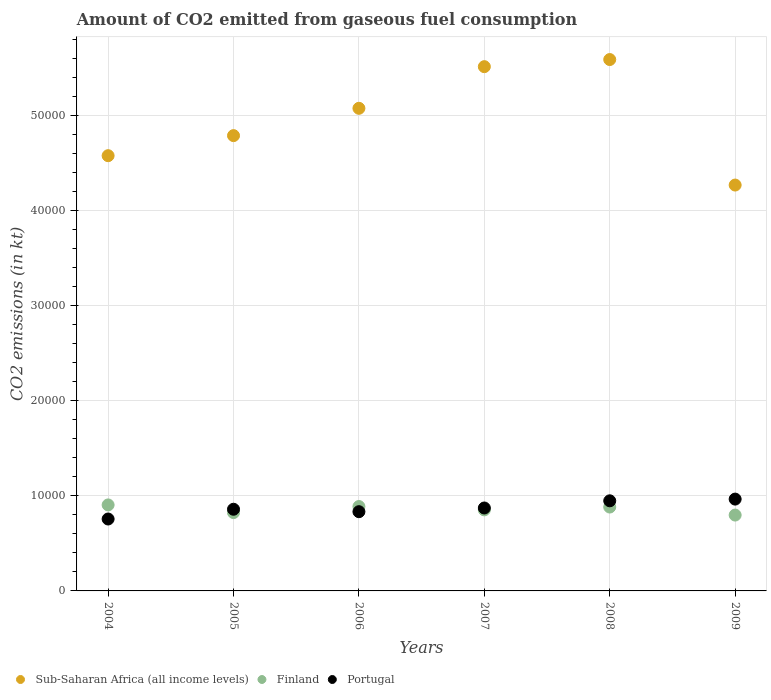Is the number of dotlines equal to the number of legend labels?
Offer a very short reply. Yes. What is the amount of CO2 emitted in Finland in 2004?
Provide a short and direct response. 9046.49. Across all years, what is the maximum amount of CO2 emitted in Finland?
Ensure brevity in your answer.  9046.49. Across all years, what is the minimum amount of CO2 emitted in Sub-Saharan Africa (all income levels)?
Provide a short and direct response. 4.27e+04. In which year was the amount of CO2 emitted in Portugal maximum?
Provide a short and direct response. 2009. In which year was the amount of CO2 emitted in Finland minimum?
Make the answer very short. 2009. What is the total amount of CO2 emitted in Finland in the graph?
Give a very brief answer. 5.15e+04. What is the difference between the amount of CO2 emitted in Sub-Saharan Africa (all income levels) in 2004 and that in 2008?
Provide a short and direct response. -1.01e+04. What is the difference between the amount of CO2 emitted in Sub-Saharan Africa (all income levels) in 2007 and the amount of CO2 emitted in Finland in 2008?
Ensure brevity in your answer.  4.63e+04. What is the average amount of CO2 emitted in Portugal per year?
Offer a very short reply. 8725.63. In the year 2005, what is the difference between the amount of CO2 emitted in Sub-Saharan Africa (all income levels) and amount of CO2 emitted in Portugal?
Offer a very short reply. 3.93e+04. What is the ratio of the amount of CO2 emitted in Finland in 2006 to that in 2009?
Give a very brief answer. 1.11. Is the difference between the amount of CO2 emitted in Sub-Saharan Africa (all income levels) in 2004 and 2005 greater than the difference between the amount of CO2 emitted in Portugal in 2004 and 2005?
Your response must be concise. No. What is the difference between the highest and the second highest amount of CO2 emitted in Sub-Saharan Africa (all income levels)?
Keep it short and to the point. 748.49. What is the difference between the highest and the lowest amount of CO2 emitted in Portugal?
Give a very brief answer. 2093.86. In how many years, is the amount of CO2 emitted in Sub-Saharan Africa (all income levels) greater than the average amount of CO2 emitted in Sub-Saharan Africa (all income levels) taken over all years?
Give a very brief answer. 3. Is the sum of the amount of CO2 emitted in Sub-Saharan Africa (all income levels) in 2005 and 2008 greater than the maximum amount of CO2 emitted in Finland across all years?
Provide a succinct answer. Yes. Does the amount of CO2 emitted in Finland monotonically increase over the years?
Provide a short and direct response. No. Is the amount of CO2 emitted in Portugal strictly greater than the amount of CO2 emitted in Finland over the years?
Your response must be concise. No. How many dotlines are there?
Offer a terse response. 3. How many years are there in the graph?
Give a very brief answer. 6. Are the values on the major ticks of Y-axis written in scientific E-notation?
Give a very brief answer. No. Does the graph contain any zero values?
Offer a terse response. No. Does the graph contain grids?
Offer a terse response. Yes. Where does the legend appear in the graph?
Provide a succinct answer. Bottom left. How many legend labels are there?
Your response must be concise. 3. How are the legend labels stacked?
Provide a succinct answer. Horizontal. What is the title of the graph?
Your answer should be very brief. Amount of CO2 emitted from gaseous fuel consumption. Does "Georgia" appear as one of the legend labels in the graph?
Make the answer very short. No. What is the label or title of the X-axis?
Offer a very short reply. Years. What is the label or title of the Y-axis?
Your answer should be compact. CO2 emissions (in kt). What is the CO2 emissions (in kt) of Sub-Saharan Africa (all income levels) in 2004?
Offer a very short reply. 4.58e+04. What is the CO2 emissions (in kt) in Finland in 2004?
Keep it short and to the point. 9046.49. What is the CO2 emissions (in kt) of Portugal in 2004?
Provide a succinct answer. 7565.02. What is the CO2 emissions (in kt) of Sub-Saharan Africa (all income levels) in 2005?
Provide a short and direct response. 4.79e+04. What is the CO2 emissions (in kt) of Finland in 2005?
Offer a very short reply. 8239.75. What is the CO2 emissions (in kt) of Portugal in 2005?
Provide a short and direct response. 8591.78. What is the CO2 emissions (in kt) in Sub-Saharan Africa (all income levels) in 2006?
Offer a very short reply. 5.08e+04. What is the CO2 emissions (in kt) in Finland in 2006?
Give a very brief answer. 8877.81. What is the CO2 emissions (in kt) in Portugal in 2006?
Ensure brevity in your answer.  8335.09. What is the CO2 emissions (in kt) in Sub-Saharan Africa (all income levels) in 2007?
Your response must be concise. 5.51e+04. What is the CO2 emissions (in kt) of Finland in 2007?
Give a very brief answer. 8525.77. What is the CO2 emissions (in kt) in Portugal in 2007?
Your answer should be compact. 8723.79. What is the CO2 emissions (in kt) in Sub-Saharan Africa (all income levels) in 2008?
Your response must be concise. 5.59e+04. What is the CO2 emissions (in kt) of Finland in 2008?
Your answer should be compact. 8822.8. What is the CO2 emissions (in kt) of Portugal in 2008?
Offer a terse response. 9479.19. What is the CO2 emissions (in kt) of Sub-Saharan Africa (all income levels) in 2009?
Make the answer very short. 4.27e+04. What is the CO2 emissions (in kt) in Finland in 2009?
Provide a succinct answer. 7979.39. What is the CO2 emissions (in kt) of Portugal in 2009?
Ensure brevity in your answer.  9658.88. Across all years, what is the maximum CO2 emissions (in kt) of Sub-Saharan Africa (all income levels)?
Make the answer very short. 5.59e+04. Across all years, what is the maximum CO2 emissions (in kt) of Finland?
Keep it short and to the point. 9046.49. Across all years, what is the maximum CO2 emissions (in kt) in Portugal?
Provide a short and direct response. 9658.88. Across all years, what is the minimum CO2 emissions (in kt) of Sub-Saharan Africa (all income levels)?
Ensure brevity in your answer.  4.27e+04. Across all years, what is the minimum CO2 emissions (in kt) in Finland?
Ensure brevity in your answer.  7979.39. Across all years, what is the minimum CO2 emissions (in kt) of Portugal?
Give a very brief answer. 7565.02. What is the total CO2 emissions (in kt) in Sub-Saharan Africa (all income levels) in the graph?
Your response must be concise. 2.98e+05. What is the total CO2 emissions (in kt) in Finland in the graph?
Keep it short and to the point. 5.15e+04. What is the total CO2 emissions (in kt) of Portugal in the graph?
Provide a succinct answer. 5.24e+04. What is the difference between the CO2 emissions (in kt) of Sub-Saharan Africa (all income levels) in 2004 and that in 2005?
Ensure brevity in your answer.  -2109.97. What is the difference between the CO2 emissions (in kt) in Finland in 2004 and that in 2005?
Provide a short and direct response. 806.74. What is the difference between the CO2 emissions (in kt) in Portugal in 2004 and that in 2005?
Your answer should be compact. -1026.76. What is the difference between the CO2 emissions (in kt) of Sub-Saharan Africa (all income levels) in 2004 and that in 2006?
Keep it short and to the point. -4983.6. What is the difference between the CO2 emissions (in kt) of Finland in 2004 and that in 2006?
Your answer should be very brief. 168.68. What is the difference between the CO2 emissions (in kt) in Portugal in 2004 and that in 2006?
Offer a very short reply. -770.07. What is the difference between the CO2 emissions (in kt) of Sub-Saharan Africa (all income levels) in 2004 and that in 2007?
Provide a succinct answer. -9364.6. What is the difference between the CO2 emissions (in kt) in Finland in 2004 and that in 2007?
Offer a terse response. 520.71. What is the difference between the CO2 emissions (in kt) in Portugal in 2004 and that in 2007?
Offer a very short reply. -1158.77. What is the difference between the CO2 emissions (in kt) of Sub-Saharan Africa (all income levels) in 2004 and that in 2008?
Offer a very short reply. -1.01e+04. What is the difference between the CO2 emissions (in kt) of Finland in 2004 and that in 2008?
Keep it short and to the point. 223.69. What is the difference between the CO2 emissions (in kt) of Portugal in 2004 and that in 2008?
Your answer should be compact. -1914.17. What is the difference between the CO2 emissions (in kt) of Sub-Saharan Africa (all income levels) in 2004 and that in 2009?
Provide a short and direct response. 3089.36. What is the difference between the CO2 emissions (in kt) of Finland in 2004 and that in 2009?
Your answer should be compact. 1067.1. What is the difference between the CO2 emissions (in kt) of Portugal in 2004 and that in 2009?
Offer a terse response. -2093.86. What is the difference between the CO2 emissions (in kt) of Sub-Saharan Africa (all income levels) in 2005 and that in 2006?
Your answer should be compact. -2873.62. What is the difference between the CO2 emissions (in kt) in Finland in 2005 and that in 2006?
Provide a short and direct response. -638.06. What is the difference between the CO2 emissions (in kt) in Portugal in 2005 and that in 2006?
Offer a very short reply. 256.69. What is the difference between the CO2 emissions (in kt) of Sub-Saharan Africa (all income levels) in 2005 and that in 2007?
Your response must be concise. -7254.63. What is the difference between the CO2 emissions (in kt) of Finland in 2005 and that in 2007?
Give a very brief answer. -286.03. What is the difference between the CO2 emissions (in kt) of Portugal in 2005 and that in 2007?
Your answer should be very brief. -132.01. What is the difference between the CO2 emissions (in kt) in Sub-Saharan Africa (all income levels) in 2005 and that in 2008?
Your answer should be compact. -8003.11. What is the difference between the CO2 emissions (in kt) of Finland in 2005 and that in 2008?
Make the answer very short. -583.05. What is the difference between the CO2 emissions (in kt) of Portugal in 2005 and that in 2008?
Provide a succinct answer. -887.41. What is the difference between the CO2 emissions (in kt) in Sub-Saharan Africa (all income levels) in 2005 and that in 2009?
Offer a very short reply. 5199.33. What is the difference between the CO2 emissions (in kt) in Finland in 2005 and that in 2009?
Ensure brevity in your answer.  260.36. What is the difference between the CO2 emissions (in kt) of Portugal in 2005 and that in 2009?
Give a very brief answer. -1067.1. What is the difference between the CO2 emissions (in kt) in Sub-Saharan Africa (all income levels) in 2006 and that in 2007?
Your response must be concise. -4381. What is the difference between the CO2 emissions (in kt) of Finland in 2006 and that in 2007?
Your response must be concise. 352.03. What is the difference between the CO2 emissions (in kt) of Portugal in 2006 and that in 2007?
Offer a terse response. -388.7. What is the difference between the CO2 emissions (in kt) in Sub-Saharan Africa (all income levels) in 2006 and that in 2008?
Your answer should be very brief. -5129.49. What is the difference between the CO2 emissions (in kt) in Finland in 2006 and that in 2008?
Offer a very short reply. 55.01. What is the difference between the CO2 emissions (in kt) in Portugal in 2006 and that in 2008?
Make the answer very short. -1144.1. What is the difference between the CO2 emissions (in kt) in Sub-Saharan Africa (all income levels) in 2006 and that in 2009?
Make the answer very short. 8072.96. What is the difference between the CO2 emissions (in kt) of Finland in 2006 and that in 2009?
Provide a succinct answer. 898.41. What is the difference between the CO2 emissions (in kt) in Portugal in 2006 and that in 2009?
Offer a terse response. -1323.79. What is the difference between the CO2 emissions (in kt) of Sub-Saharan Africa (all income levels) in 2007 and that in 2008?
Your answer should be very brief. -748.49. What is the difference between the CO2 emissions (in kt) of Finland in 2007 and that in 2008?
Offer a terse response. -297.03. What is the difference between the CO2 emissions (in kt) of Portugal in 2007 and that in 2008?
Give a very brief answer. -755.4. What is the difference between the CO2 emissions (in kt) of Sub-Saharan Africa (all income levels) in 2007 and that in 2009?
Keep it short and to the point. 1.25e+04. What is the difference between the CO2 emissions (in kt) in Finland in 2007 and that in 2009?
Keep it short and to the point. 546.38. What is the difference between the CO2 emissions (in kt) in Portugal in 2007 and that in 2009?
Make the answer very short. -935.09. What is the difference between the CO2 emissions (in kt) of Sub-Saharan Africa (all income levels) in 2008 and that in 2009?
Provide a succinct answer. 1.32e+04. What is the difference between the CO2 emissions (in kt) in Finland in 2008 and that in 2009?
Your answer should be very brief. 843.41. What is the difference between the CO2 emissions (in kt) of Portugal in 2008 and that in 2009?
Keep it short and to the point. -179.68. What is the difference between the CO2 emissions (in kt) in Sub-Saharan Africa (all income levels) in 2004 and the CO2 emissions (in kt) in Finland in 2005?
Provide a succinct answer. 3.75e+04. What is the difference between the CO2 emissions (in kt) in Sub-Saharan Africa (all income levels) in 2004 and the CO2 emissions (in kt) in Portugal in 2005?
Make the answer very short. 3.72e+04. What is the difference between the CO2 emissions (in kt) of Finland in 2004 and the CO2 emissions (in kt) of Portugal in 2005?
Your response must be concise. 454.71. What is the difference between the CO2 emissions (in kt) of Sub-Saharan Africa (all income levels) in 2004 and the CO2 emissions (in kt) of Finland in 2006?
Offer a very short reply. 3.69e+04. What is the difference between the CO2 emissions (in kt) in Sub-Saharan Africa (all income levels) in 2004 and the CO2 emissions (in kt) in Portugal in 2006?
Your answer should be very brief. 3.74e+04. What is the difference between the CO2 emissions (in kt) of Finland in 2004 and the CO2 emissions (in kt) of Portugal in 2006?
Your answer should be very brief. 711.4. What is the difference between the CO2 emissions (in kt) in Sub-Saharan Africa (all income levels) in 2004 and the CO2 emissions (in kt) in Finland in 2007?
Your answer should be compact. 3.73e+04. What is the difference between the CO2 emissions (in kt) in Sub-Saharan Africa (all income levels) in 2004 and the CO2 emissions (in kt) in Portugal in 2007?
Ensure brevity in your answer.  3.71e+04. What is the difference between the CO2 emissions (in kt) in Finland in 2004 and the CO2 emissions (in kt) in Portugal in 2007?
Make the answer very short. 322.7. What is the difference between the CO2 emissions (in kt) of Sub-Saharan Africa (all income levels) in 2004 and the CO2 emissions (in kt) of Finland in 2008?
Your response must be concise. 3.70e+04. What is the difference between the CO2 emissions (in kt) in Sub-Saharan Africa (all income levels) in 2004 and the CO2 emissions (in kt) in Portugal in 2008?
Provide a succinct answer. 3.63e+04. What is the difference between the CO2 emissions (in kt) of Finland in 2004 and the CO2 emissions (in kt) of Portugal in 2008?
Provide a succinct answer. -432.71. What is the difference between the CO2 emissions (in kt) in Sub-Saharan Africa (all income levels) in 2004 and the CO2 emissions (in kt) in Finland in 2009?
Your answer should be compact. 3.78e+04. What is the difference between the CO2 emissions (in kt) of Sub-Saharan Africa (all income levels) in 2004 and the CO2 emissions (in kt) of Portugal in 2009?
Provide a succinct answer. 3.61e+04. What is the difference between the CO2 emissions (in kt) in Finland in 2004 and the CO2 emissions (in kt) in Portugal in 2009?
Your response must be concise. -612.39. What is the difference between the CO2 emissions (in kt) in Sub-Saharan Africa (all income levels) in 2005 and the CO2 emissions (in kt) in Finland in 2006?
Provide a short and direct response. 3.90e+04. What is the difference between the CO2 emissions (in kt) in Sub-Saharan Africa (all income levels) in 2005 and the CO2 emissions (in kt) in Portugal in 2006?
Your answer should be very brief. 3.96e+04. What is the difference between the CO2 emissions (in kt) of Finland in 2005 and the CO2 emissions (in kt) of Portugal in 2006?
Your response must be concise. -95.34. What is the difference between the CO2 emissions (in kt) of Sub-Saharan Africa (all income levels) in 2005 and the CO2 emissions (in kt) of Finland in 2007?
Offer a terse response. 3.94e+04. What is the difference between the CO2 emissions (in kt) in Sub-Saharan Africa (all income levels) in 2005 and the CO2 emissions (in kt) in Portugal in 2007?
Provide a short and direct response. 3.92e+04. What is the difference between the CO2 emissions (in kt) in Finland in 2005 and the CO2 emissions (in kt) in Portugal in 2007?
Ensure brevity in your answer.  -484.04. What is the difference between the CO2 emissions (in kt) of Sub-Saharan Africa (all income levels) in 2005 and the CO2 emissions (in kt) of Finland in 2008?
Your answer should be very brief. 3.91e+04. What is the difference between the CO2 emissions (in kt) of Sub-Saharan Africa (all income levels) in 2005 and the CO2 emissions (in kt) of Portugal in 2008?
Your response must be concise. 3.84e+04. What is the difference between the CO2 emissions (in kt) in Finland in 2005 and the CO2 emissions (in kt) in Portugal in 2008?
Your response must be concise. -1239.45. What is the difference between the CO2 emissions (in kt) in Sub-Saharan Africa (all income levels) in 2005 and the CO2 emissions (in kt) in Finland in 2009?
Offer a terse response. 3.99e+04. What is the difference between the CO2 emissions (in kt) in Sub-Saharan Africa (all income levels) in 2005 and the CO2 emissions (in kt) in Portugal in 2009?
Make the answer very short. 3.82e+04. What is the difference between the CO2 emissions (in kt) in Finland in 2005 and the CO2 emissions (in kt) in Portugal in 2009?
Ensure brevity in your answer.  -1419.13. What is the difference between the CO2 emissions (in kt) in Sub-Saharan Africa (all income levels) in 2006 and the CO2 emissions (in kt) in Finland in 2007?
Your answer should be compact. 4.22e+04. What is the difference between the CO2 emissions (in kt) in Sub-Saharan Africa (all income levels) in 2006 and the CO2 emissions (in kt) in Portugal in 2007?
Provide a succinct answer. 4.20e+04. What is the difference between the CO2 emissions (in kt) of Finland in 2006 and the CO2 emissions (in kt) of Portugal in 2007?
Provide a short and direct response. 154.01. What is the difference between the CO2 emissions (in kt) in Sub-Saharan Africa (all income levels) in 2006 and the CO2 emissions (in kt) in Finland in 2008?
Your answer should be compact. 4.19e+04. What is the difference between the CO2 emissions (in kt) of Sub-Saharan Africa (all income levels) in 2006 and the CO2 emissions (in kt) of Portugal in 2008?
Keep it short and to the point. 4.13e+04. What is the difference between the CO2 emissions (in kt) in Finland in 2006 and the CO2 emissions (in kt) in Portugal in 2008?
Make the answer very short. -601.39. What is the difference between the CO2 emissions (in kt) of Sub-Saharan Africa (all income levels) in 2006 and the CO2 emissions (in kt) of Finland in 2009?
Give a very brief answer. 4.28e+04. What is the difference between the CO2 emissions (in kt) in Sub-Saharan Africa (all income levels) in 2006 and the CO2 emissions (in kt) in Portugal in 2009?
Offer a very short reply. 4.11e+04. What is the difference between the CO2 emissions (in kt) in Finland in 2006 and the CO2 emissions (in kt) in Portugal in 2009?
Give a very brief answer. -781.07. What is the difference between the CO2 emissions (in kt) in Sub-Saharan Africa (all income levels) in 2007 and the CO2 emissions (in kt) in Finland in 2008?
Ensure brevity in your answer.  4.63e+04. What is the difference between the CO2 emissions (in kt) of Sub-Saharan Africa (all income levels) in 2007 and the CO2 emissions (in kt) of Portugal in 2008?
Make the answer very short. 4.57e+04. What is the difference between the CO2 emissions (in kt) in Finland in 2007 and the CO2 emissions (in kt) in Portugal in 2008?
Keep it short and to the point. -953.42. What is the difference between the CO2 emissions (in kt) of Sub-Saharan Africa (all income levels) in 2007 and the CO2 emissions (in kt) of Finland in 2009?
Your answer should be compact. 4.72e+04. What is the difference between the CO2 emissions (in kt) in Sub-Saharan Africa (all income levels) in 2007 and the CO2 emissions (in kt) in Portugal in 2009?
Make the answer very short. 4.55e+04. What is the difference between the CO2 emissions (in kt) of Finland in 2007 and the CO2 emissions (in kt) of Portugal in 2009?
Keep it short and to the point. -1133.1. What is the difference between the CO2 emissions (in kt) of Sub-Saharan Africa (all income levels) in 2008 and the CO2 emissions (in kt) of Finland in 2009?
Offer a very short reply. 4.79e+04. What is the difference between the CO2 emissions (in kt) in Sub-Saharan Africa (all income levels) in 2008 and the CO2 emissions (in kt) in Portugal in 2009?
Provide a short and direct response. 4.62e+04. What is the difference between the CO2 emissions (in kt) in Finland in 2008 and the CO2 emissions (in kt) in Portugal in 2009?
Provide a short and direct response. -836.08. What is the average CO2 emissions (in kt) of Sub-Saharan Africa (all income levels) per year?
Give a very brief answer. 4.97e+04. What is the average CO2 emissions (in kt) of Finland per year?
Your response must be concise. 8582. What is the average CO2 emissions (in kt) in Portugal per year?
Provide a short and direct response. 8725.63. In the year 2004, what is the difference between the CO2 emissions (in kt) of Sub-Saharan Africa (all income levels) and CO2 emissions (in kt) of Finland?
Offer a very short reply. 3.67e+04. In the year 2004, what is the difference between the CO2 emissions (in kt) of Sub-Saharan Africa (all income levels) and CO2 emissions (in kt) of Portugal?
Provide a succinct answer. 3.82e+04. In the year 2004, what is the difference between the CO2 emissions (in kt) of Finland and CO2 emissions (in kt) of Portugal?
Give a very brief answer. 1481.47. In the year 2005, what is the difference between the CO2 emissions (in kt) of Sub-Saharan Africa (all income levels) and CO2 emissions (in kt) of Finland?
Offer a terse response. 3.97e+04. In the year 2005, what is the difference between the CO2 emissions (in kt) of Sub-Saharan Africa (all income levels) and CO2 emissions (in kt) of Portugal?
Your answer should be very brief. 3.93e+04. In the year 2005, what is the difference between the CO2 emissions (in kt) of Finland and CO2 emissions (in kt) of Portugal?
Your answer should be very brief. -352.03. In the year 2006, what is the difference between the CO2 emissions (in kt) in Sub-Saharan Africa (all income levels) and CO2 emissions (in kt) in Finland?
Your answer should be compact. 4.19e+04. In the year 2006, what is the difference between the CO2 emissions (in kt) of Sub-Saharan Africa (all income levels) and CO2 emissions (in kt) of Portugal?
Your answer should be very brief. 4.24e+04. In the year 2006, what is the difference between the CO2 emissions (in kt) of Finland and CO2 emissions (in kt) of Portugal?
Provide a succinct answer. 542.72. In the year 2007, what is the difference between the CO2 emissions (in kt) of Sub-Saharan Africa (all income levels) and CO2 emissions (in kt) of Finland?
Offer a very short reply. 4.66e+04. In the year 2007, what is the difference between the CO2 emissions (in kt) in Sub-Saharan Africa (all income levels) and CO2 emissions (in kt) in Portugal?
Offer a terse response. 4.64e+04. In the year 2007, what is the difference between the CO2 emissions (in kt) in Finland and CO2 emissions (in kt) in Portugal?
Your answer should be compact. -198.02. In the year 2008, what is the difference between the CO2 emissions (in kt) of Sub-Saharan Africa (all income levels) and CO2 emissions (in kt) of Finland?
Your answer should be compact. 4.71e+04. In the year 2008, what is the difference between the CO2 emissions (in kt) in Sub-Saharan Africa (all income levels) and CO2 emissions (in kt) in Portugal?
Provide a succinct answer. 4.64e+04. In the year 2008, what is the difference between the CO2 emissions (in kt) in Finland and CO2 emissions (in kt) in Portugal?
Keep it short and to the point. -656.39. In the year 2009, what is the difference between the CO2 emissions (in kt) in Sub-Saharan Africa (all income levels) and CO2 emissions (in kt) in Finland?
Provide a short and direct response. 3.47e+04. In the year 2009, what is the difference between the CO2 emissions (in kt) in Sub-Saharan Africa (all income levels) and CO2 emissions (in kt) in Portugal?
Your answer should be very brief. 3.30e+04. In the year 2009, what is the difference between the CO2 emissions (in kt) of Finland and CO2 emissions (in kt) of Portugal?
Provide a succinct answer. -1679.49. What is the ratio of the CO2 emissions (in kt) of Sub-Saharan Africa (all income levels) in 2004 to that in 2005?
Ensure brevity in your answer.  0.96. What is the ratio of the CO2 emissions (in kt) in Finland in 2004 to that in 2005?
Your answer should be very brief. 1.1. What is the ratio of the CO2 emissions (in kt) of Portugal in 2004 to that in 2005?
Provide a short and direct response. 0.88. What is the ratio of the CO2 emissions (in kt) in Sub-Saharan Africa (all income levels) in 2004 to that in 2006?
Offer a terse response. 0.9. What is the ratio of the CO2 emissions (in kt) of Portugal in 2004 to that in 2006?
Provide a short and direct response. 0.91. What is the ratio of the CO2 emissions (in kt) of Sub-Saharan Africa (all income levels) in 2004 to that in 2007?
Offer a very short reply. 0.83. What is the ratio of the CO2 emissions (in kt) of Finland in 2004 to that in 2007?
Make the answer very short. 1.06. What is the ratio of the CO2 emissions (in kt) in Portugal in 2004 to that in 2007?
Make the answer very short. 0.87. What is the ratio of the CO2 emissions (in kt) of Sub-Saharan Africa (all income levels) in 2004 to that in 2008?
Make the answer very short. 0.82. What is the ratio of the CO2 emissions (in kt) of Finland in 2004 to that in 2008?
Offer a terse response. 1.03. What is the ratio of the CO2 emissions (in kt) of Portugal in 2004 to that in 2008?
Provide a short and direct response. 0.8. What is the ratio of the CO2 emissions (in kt) of Sub-Saharan Africa (all income levels) in 2004 to that in 2009?
Your answer should be compact. 1.07. What is the ratio of the CO2 emissions (in kt) of Finland in 2004 to that in 2009?
Provide a succinct answer. 1.13. What is the ratio of the CO2 emissions (in kt) in Portugal in 2004 to that in 2009?
Offer a very short reply. 0.78. What is the ratio of the CO2 emissions (in kt) in Sub-Saharan Africa (all income levels) in 2005 to that in 2006?
Ensure brevity in your answer.  0.94. What is the ratio of the CO2 emissions (in kt) of Finland in 2005 to that in 2006?
Your answer should be very brief. 0.93. What is the ratio of the CO2 emissions (in kt) of Portugal in 2005 to that in 2006?
Keep it short and to the point. 1.03. What is the ratio of the CO2 emissions (in kt) in Sub-Saharan Africa (all income levels) in 2005 to that in 2007?
Offer a very short reply. 0.87. What is the ratio of the CO2 emissions (in kt) in Finland in 2005 to that in 2007?
Offer a terse response. 0.97. What is the ratio of the CO2 emissions (in kt) in Portugal in 2005 to that in 2007?
Your answer should be compact. 0.98. What is the ratio of the CO2 emissions (in kt) in Sub-Saharan Africa (all income levels) in 2005 to that in 2008?
Keep it short and to the point. 0.86. What is the ratio of the CO2 emissions (in kt) in Finland in 2005 to that in 2008?
Provide a short and direct response. 0.93. What is the ratio of the CO2 emissions (in kt) of Portugal in 2005 to that in 2008?
Provide a succinct answer. 0.91. What is the ratio of the CO2 emissions (in kt) of Sub-Saharan Africa (all income levels) in 2005 to that in 2009?
Provide a succinct answer. 1.12. What is the ratio of the CO2 emissions (in kt) of Finland in 2005 to that in 2009?
Offer a very short reply. 1.03. What is the ratio of the CO2 emissions (in kt) in Portugal in 2005 to that in 2009?
Provide a short and direct response. 0.89. What is the ratio of the CO2 emissions (in kt) in Sub-Saharan Africa (all income levels) in 2006 to that in 2007?
Keep it short and to the point. 0.92. What is the ratio of the CO2 emissions (in kt) of Finland in 2006 to that in 2007?
Your answer should be compact. 1.04. What is the ratio of the CO2 emissions (in kt) of Portugal in 2006 to that in 2007?
Your response must be concise. 0.96. What is the ratio of the CO2 emissions (in kt) of Sub-Saharan Africa (all income levels) in 2006 to that in 2008?
Your answer should be compact. 0.91. What is the ratio of the CO2 emissions (in kt) of Portugal in 2006 to that in 2008?
Make the answer very short. 0.88. What is the ratio of the CO2 emissions (in kt) in Sub-Saharan Africa (all income levels) in 2006 to that in 2009?
Your answer should be very brief. 1.19. What is the ratio of the CO2 emissions (in kt) in Finland in 2006 to that in 2009?
Provide a succinct answer. 1.11. What is the ratio of the CO2 emissions (in kt) of Portugal in 2006 to that in 2009?
Offer a very short reply. 0.86. What is the ratio of the CO2 emissions (in kt) of Sub-Saharan Africa (all income levels) in 2007 to that in 2008?
Offer a very short reply. 0.99. What is the ratio of the CO2 emissions (in kt) of Finland in 2007 to that in 2008?
Give a very brief answer. 0.97. What is the ratio of the CO2 emissions (in kt) in Portugal in 2007 to that in 2008?
Make the answer very short. 0.92. What is the ratio of the CO2 emissions (in kt) in Sub-Saharan Africa (all income levels) in 2007 to that in 2009?
Your answer should be very brief. 1.29. What is the ratio of the CO2 emissions (in kt) in Finland in 2007 to that in 2009?
Your response must be concise. 1.07. What is the ratio of the CO2 emissions (in kt) in Portugal in 2007 to that in 2009?
Your answer should be compact. 0.9. What is the ratio of the CO2 emissions (in kt) of Sub-Saharan Africa (all income levels) in 2008 to that in 2009?
Offer a very short reply. 1.31. What is the ratio of the CO2 emissions (in kt) of Finland in 2008 to that in 2009?
Provide a short and direct response. 1.11. What is the ratio of the CO2 emissions (in kt) in Portugal in 2008 to that in 2009?
Give a very brief answer. 0.98. What is the difference between the highest and the second highest CO2 emissions (in kt) of Sub-Saharan Africa (all income levels)?
Your answer should be very brief. 748.49. What is the difference between the highest and the second highest CO2 emissions (in kt) in Finland?
Make the answer very short. 168.68. What is the difference between the highest and the second highest CO2 emissions (in kt) of Portugal?
Your answer should be very brief. 179.68. What is the difference between the highest and the lowest CO2 emissions (in kt) of Sub-Saharan Africa (all income levels)?
Your answer should be very brief. 1.32e+04. What is the difference between the highest and the lowest CO2 emissions (in kt) in Finland?
Offer a very short reply. 1067.1. What is the difference between the highest and the lowest CO2 emissions (in kt) of Portugal?
Provide a succinct answer. 2093.86. 